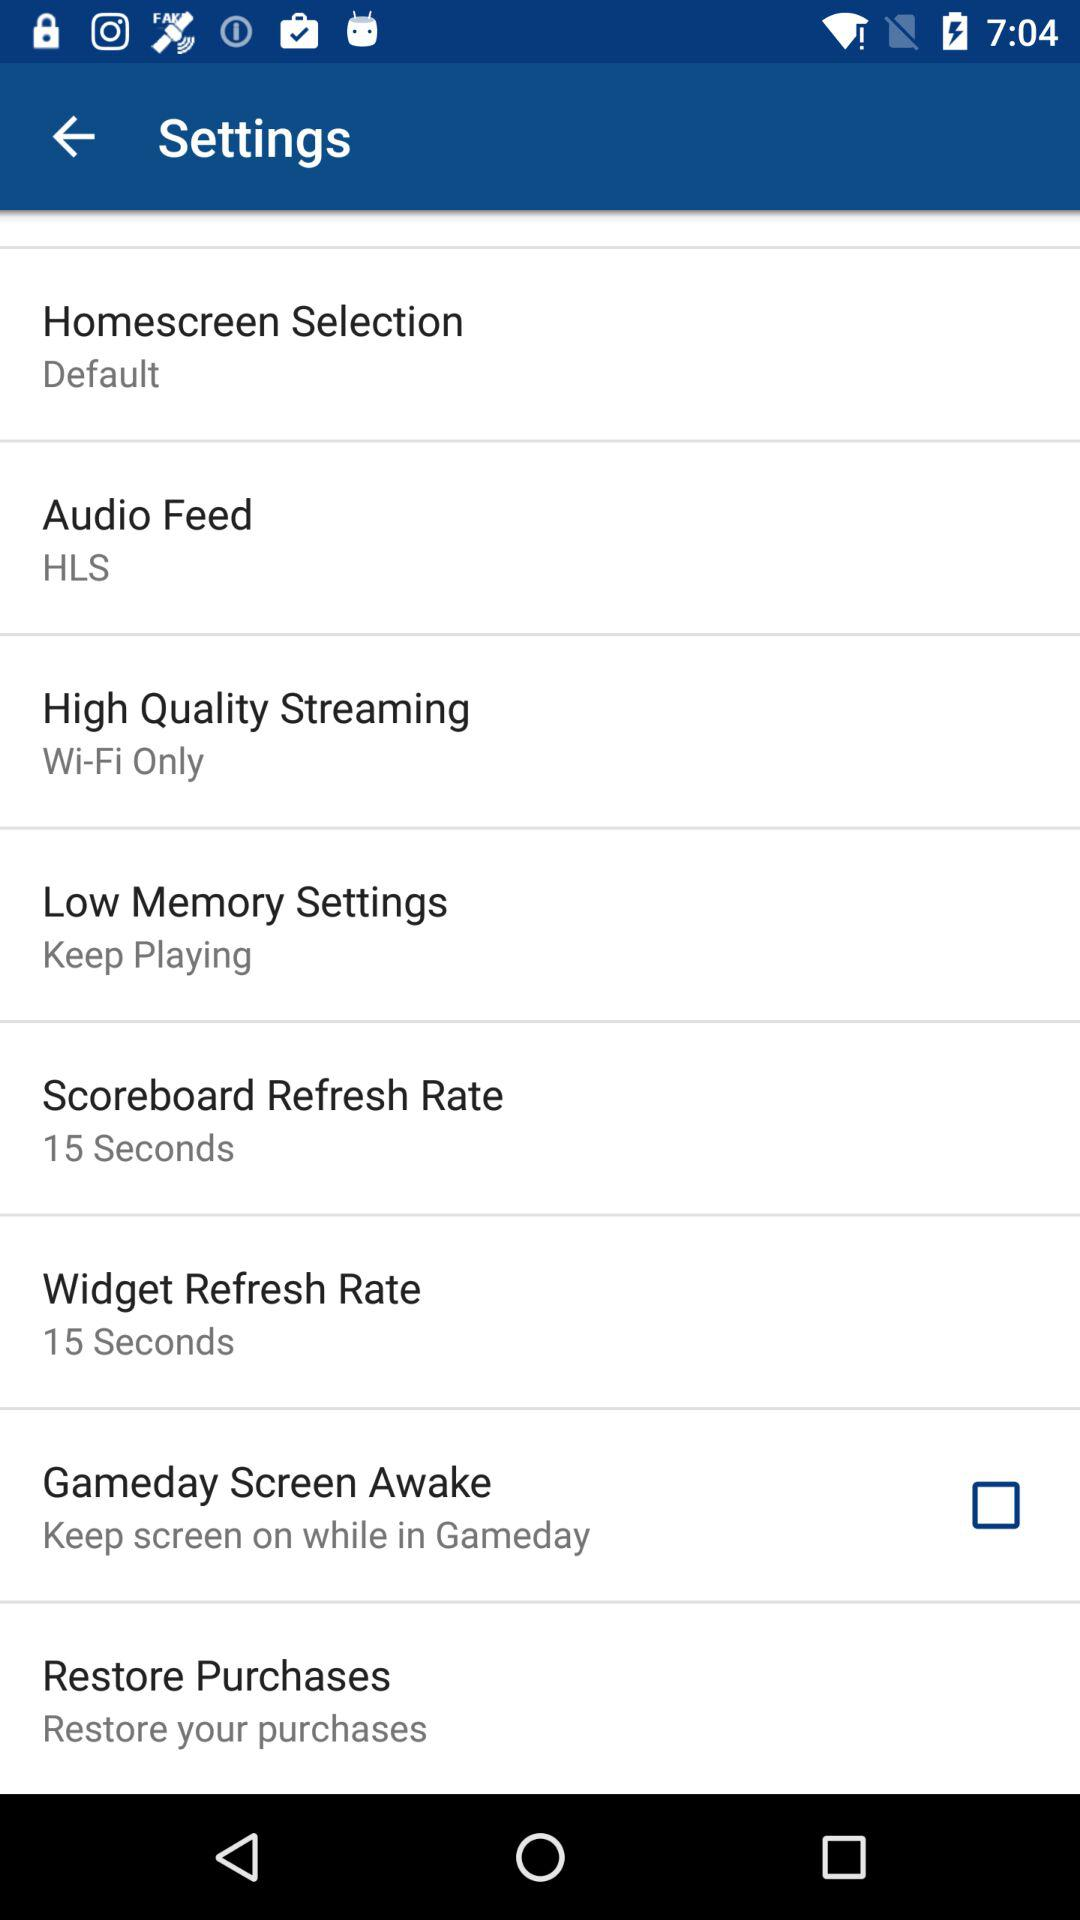What is the status of the "Gameday Screen Awake"? The status is "off". 